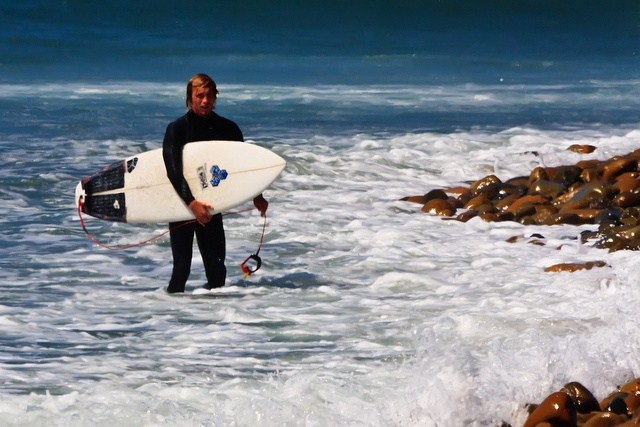Describe the objects in this image and their specific colors. I can see surfboard in darkblue, lightgray, black, tan, and darkgray tones and people in darkblue, black, maroon, gray, and brown tones in this image. 